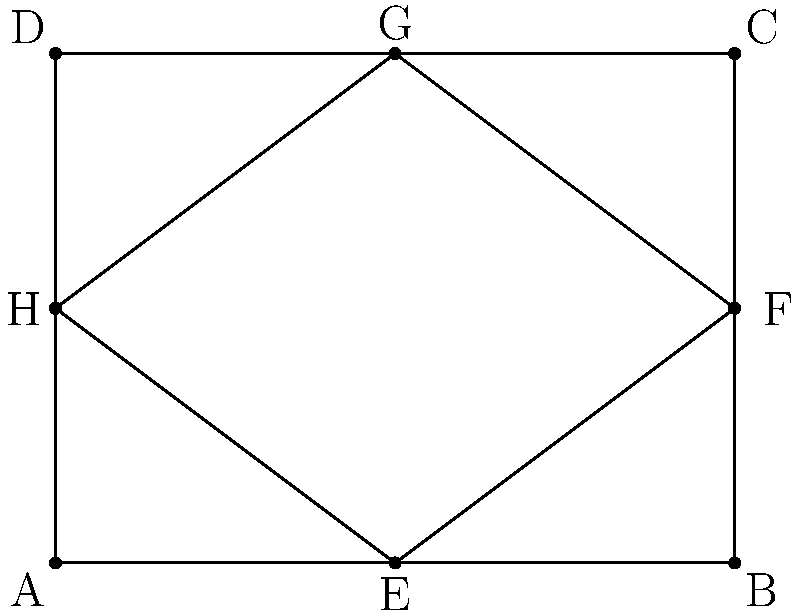In redesigning the school library floor plan, you notice that the central reading area EFGH is congruent to the outer rectangle ABCD. If the perimeter of ABCD is 14 units, what is the area of the central reading area EFGH? Let's approach this step-by-step:

1) First, we need to understand what congruence means. Congruent shapes have the same size and shape, which implies that EFGH is a scaled-down version of ABCD.

2) We're given that the perimeter of ABCD is 14 units. Let's call the width of ABCD $w$ and its height $h$.

3) The perimeter formula gives us: $2w + 2h = 14$

4) From the diagram, we can see that ABCD is a rectangle. In rectangles, opposite sides are equal. So, AB = DC and AD = BC.

5) Looking at EFGH, we can see that EF = 1/2 AB, FG = 1/2 BC, GH = 1/2 DC, and HE = 1/2 AD.

6) This means that both the width and height of EFGH are half of ABCD's dimensions.

7) Let's express the dimensions of ABCD in terms of $w$:
   Width of ABCD = $w$
   Height of ABCD = $\frac{14 - 2w}{2} = 7 - w$ (from step 3)

8) The area of a rectangle is width * height. So the area of EFGH is:
   Area of EFGH = $\frac{w}{2} * \frac{7-w}{2} = \frac{7w - w^2}{4}$

9) To maximize this area, we can differentiate and set to zero:
   $\frac{d}{dw}(\frac{7w - w^2}{4}) = \frac{7 - 2w}{4} = 0$
   $7 - 2w = 0$
   $w = 3.5$

10) This gives us the dimensions of ABCD: 3.5 x 3.5

11) Therefore, the dimensions of EFGH are: 1.75 x 1.75

12) The area of EFGH is thus: $1.75 * 1.75 = 3.0625$ square units
Answer: $3.0625$ square units 